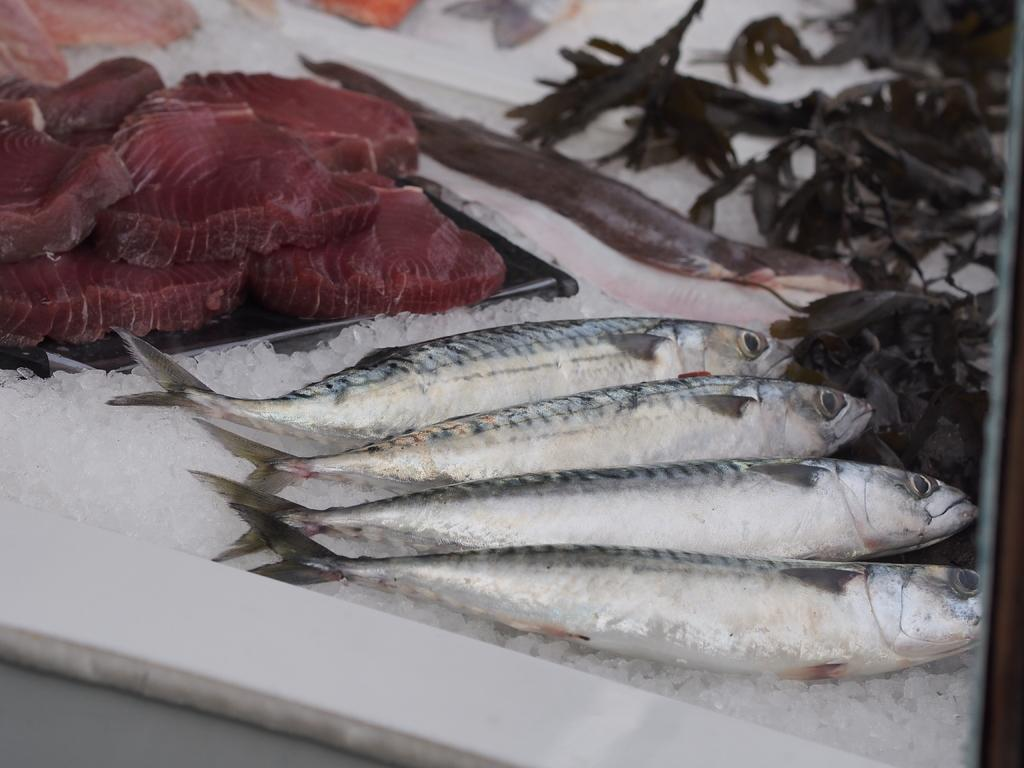What type of animals can be seen in the image? There are fishes in the image. What other food item is present in the image besides the fishes? There is meat in the image. What is used to keep the food items cold in the image? There are ice pieces in the image. Can you describe any other unspecified items in the image? Unfortunately, the provided facts do not specify what these other unspecified items are. What type of pipe can be seen in the image? There is no pipe present in the image. Can you describe the mist surrounding the fishes in the image? There is no mist present in the image; the fishes are surrounded by water. 